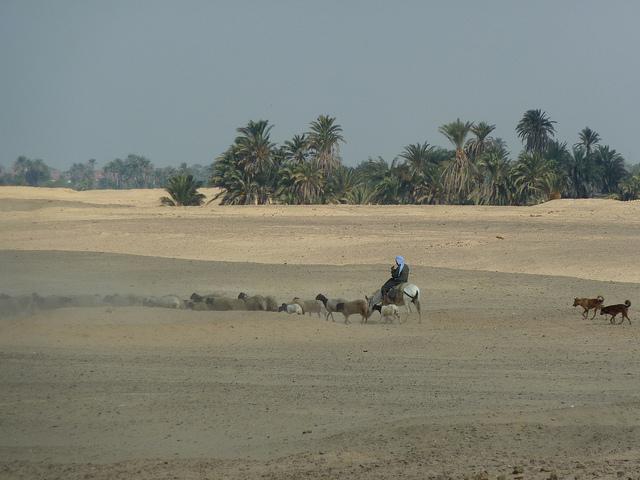Where is the man riding through?
Indicate the correct choice and explain in the format: 'Answer: answer
Rationale: rationale.'
Options: Yard, forest, desert, parking lot. Answer: desert.
Rationale: The area is covered in sand. 